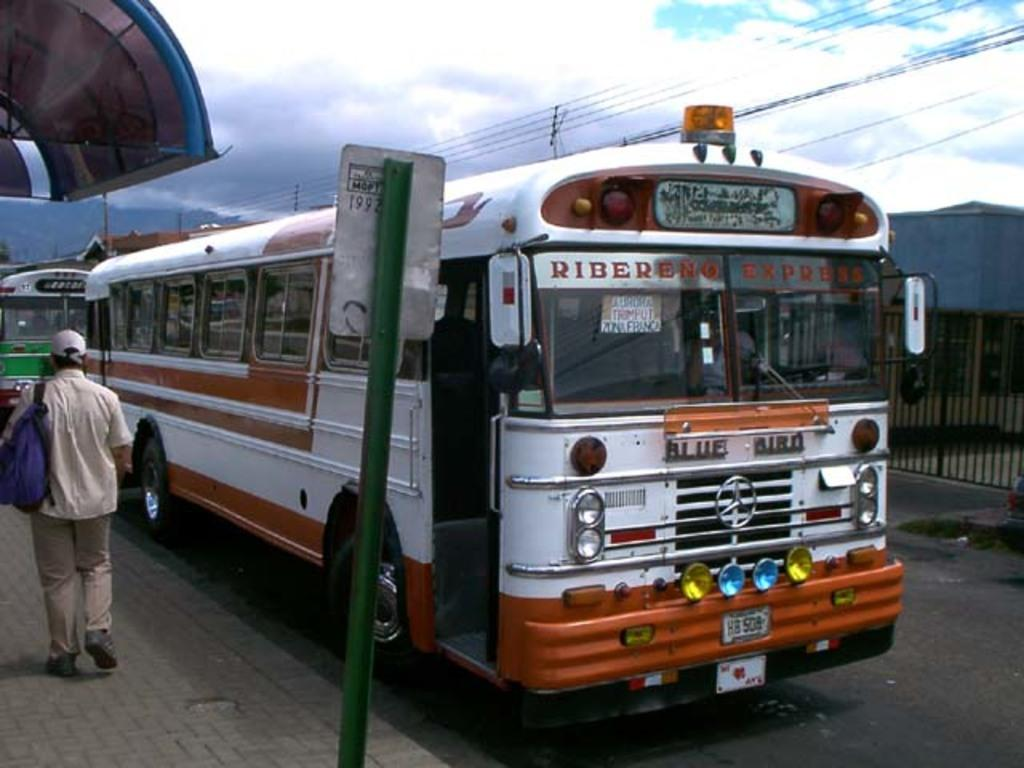What is happening at the left side of the image? There is a person walking at the left side of the image. What can be seen in the image besides the person walking? There is a sign board, buses on the road, fencing at the right side, buildings, and wires visible at the top of the image. Can you tell me how many aunts are helping the person in the image? There are no aunts present in the image, and the person is not receiving any help. 